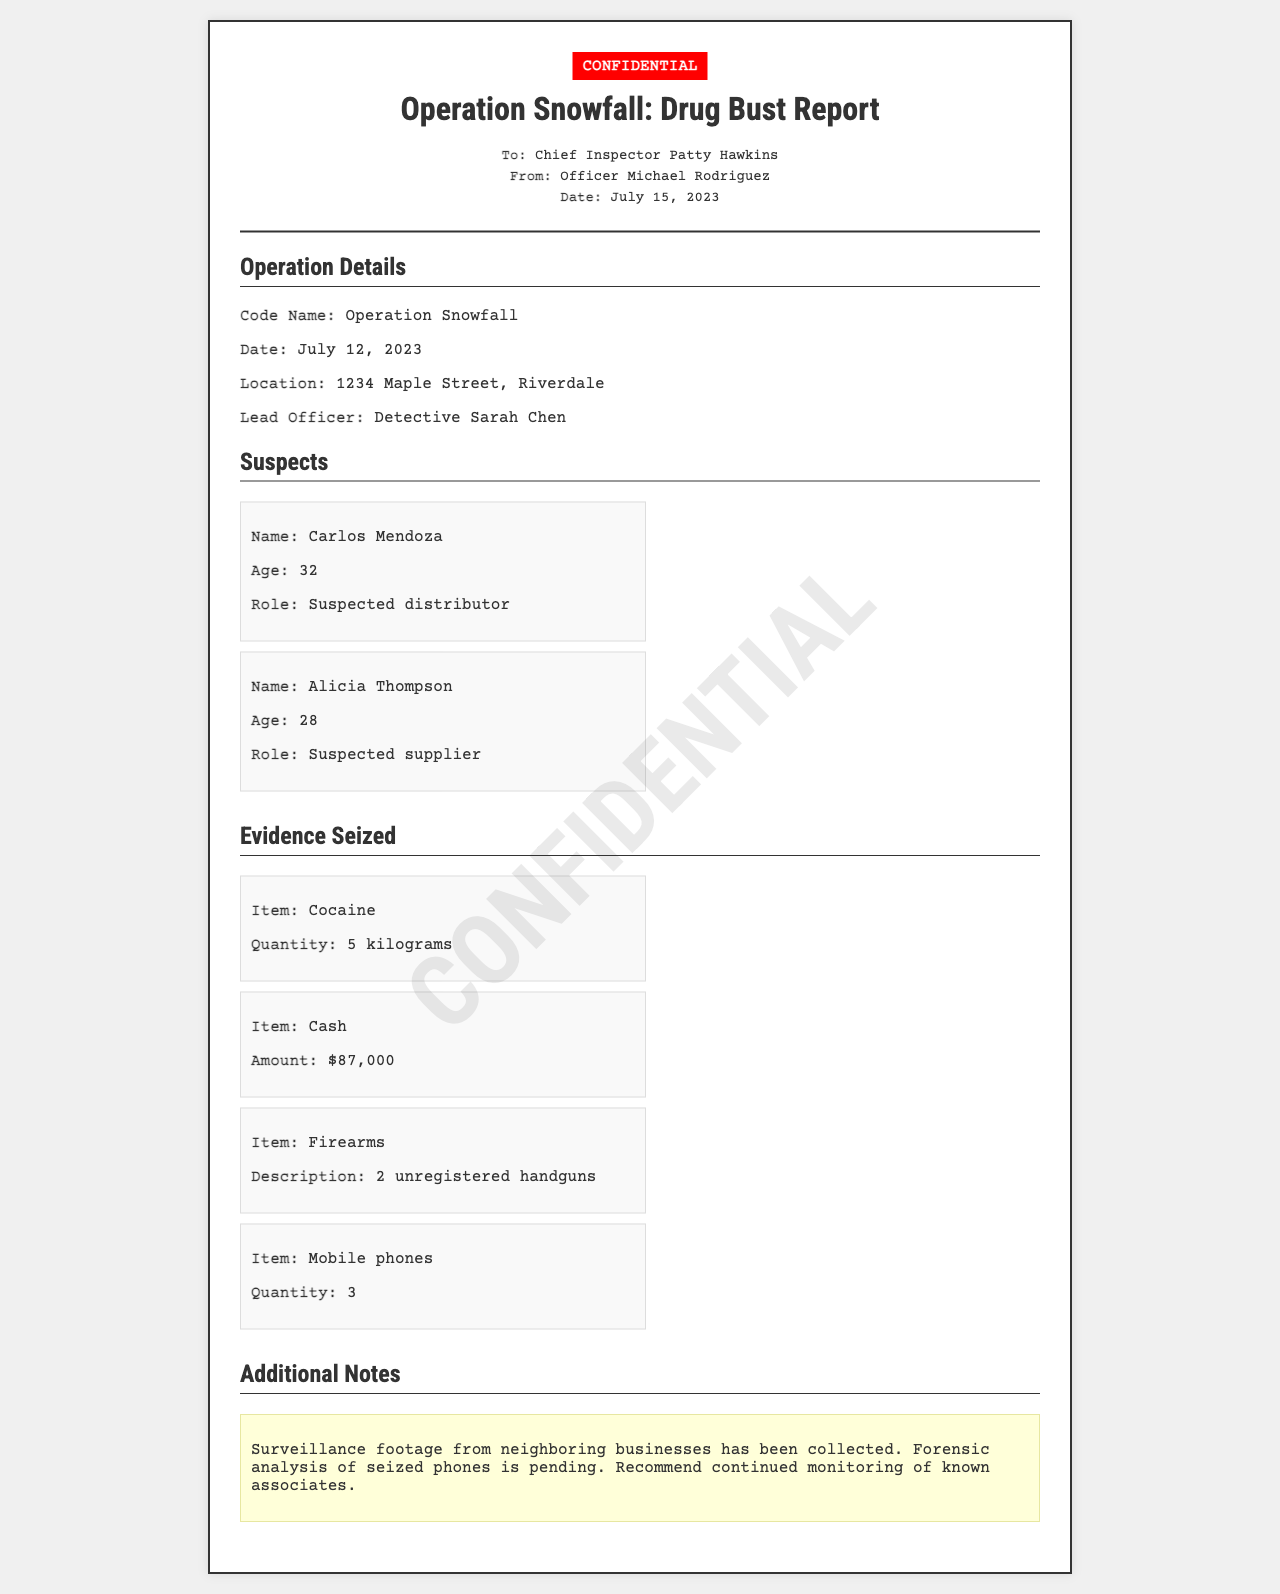What is the code name of the operation? The code name of the operation is mentioned in the document as "Operation Snowfall."
Answer: Operation Snowfall Who is the lead officer for this operation? The document specifies that the lead officer is Detective Sarah Chen.
Answer: Detective Sarah Chen How many kilograms of cocaine were seized? The document states that 5 kilograms of cocaine were seized during the operation.
Answer: 5 kilograms What was the amount of cash seized? According to the document, the amount of cash seized was $87,000.
Answer: $87,000 Who is suspected of being a distributor? The document identifies Carlos Mendoza as the suspected distributor in this operation.
Answer: Carlos Mendoza How many unregistered handguns were seized? The document indicates that 2 unregistered handguns were seized as evidence in the operation.
Answer: 2 unregistered handguns What is the date of the operation? The date of the operation is stated to be July 12, 2023, in the document.
Answer: July 12, 2023 What did the additional notes mention about surveillance? The additional notes mention that surveillance footage from neighboring businesses has been collected.
Answer: Collected What is pending analysis according to the notes? The notes indicate that forensic analysis of seized phones is pending.
Answer: Pending How many suspects are listed in the document? There are two suspects listed in the document: Carlos Mendoza and Alicia Thompson.
Answer: Two 